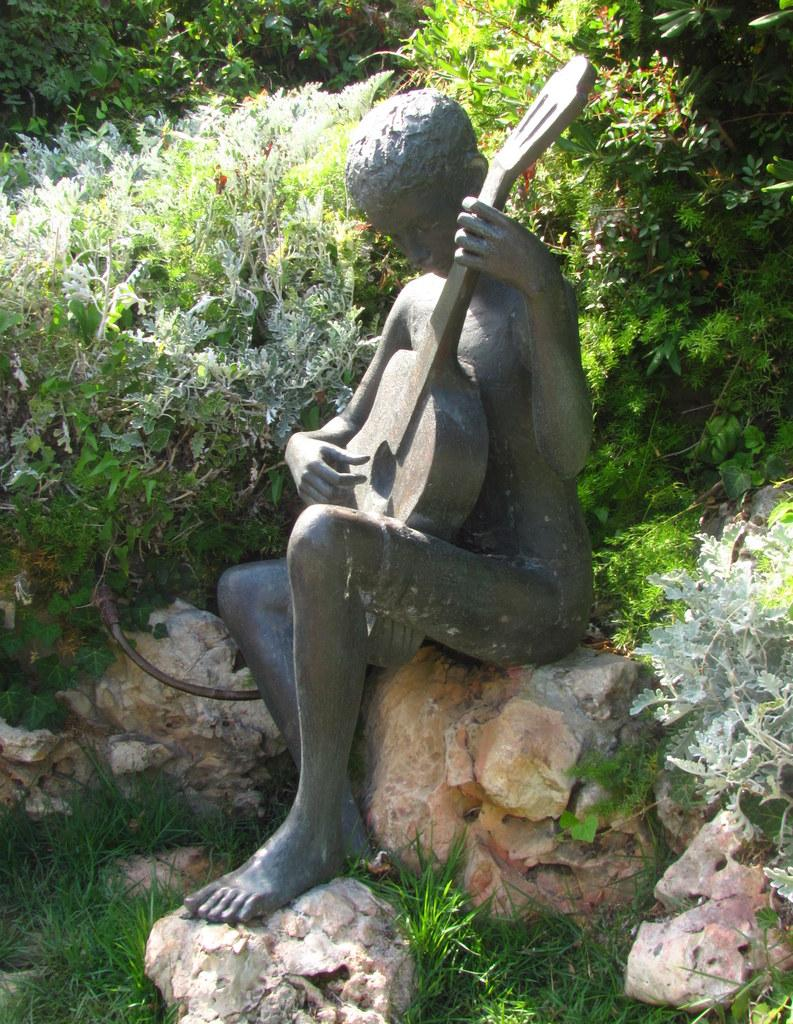What is the main subject in the foreground of the image? There is a sculpture in the foreground of the image. What is the sculpture sitting on? The sculpture is sitting on a rock. What type of vegetation is present in the foreground of the image? There is grass and a stone in the foreground of the image. What can be seen in the background of the image? There are plants in the background of the image. Can you hear the sound of waves crashing in the image? There is no reference to waves or any sounds in the image, so it's not possible to determine if waves can be heard. Is there a donkey visible in the image? There is no donkey present in the image. 